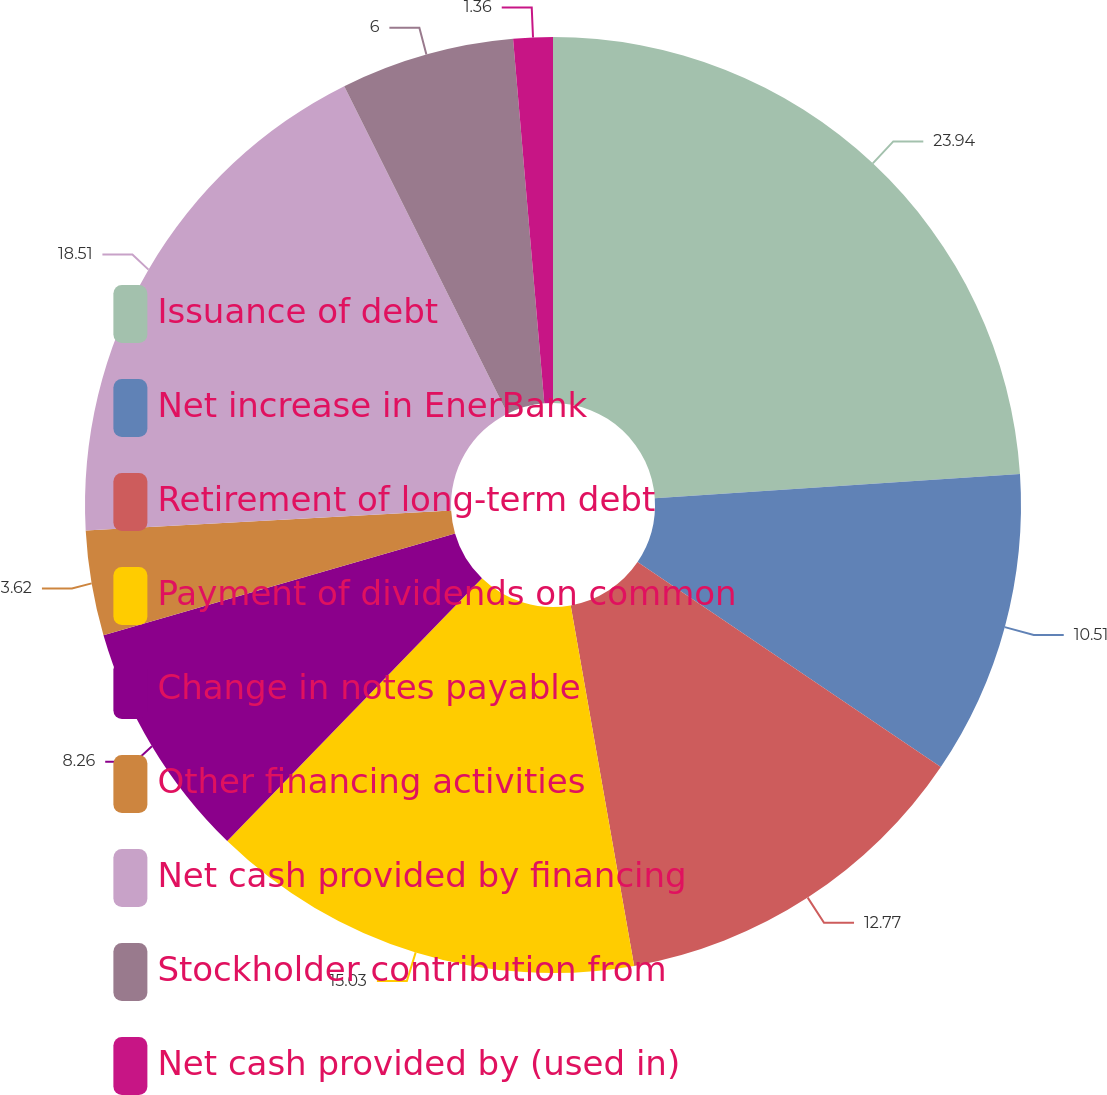Convert chart to OTSL. <chart><loc_0><loc_0><loc_500><loc_500><pie_chart><fcel>Issuance of debt<fcel>Net increase in EnerBank<fcel>Retirement of long-term debt<fcel>Payment of dividends on common<fcel>Change in notes payable<fcel>Other financing activities<fcel>Net cash provided by financing<fcel>Stockholder contribution from<fcel>Net cash provided by (used in)<nl><fcel>23.95%<fcel>10.51%<fcel>12.77%<fcel>15.03%<fcel>8.26%<fcel>3.62%<fcel>18.51%<fcel>6.0%<fcel>1.36%<nl></chart> 